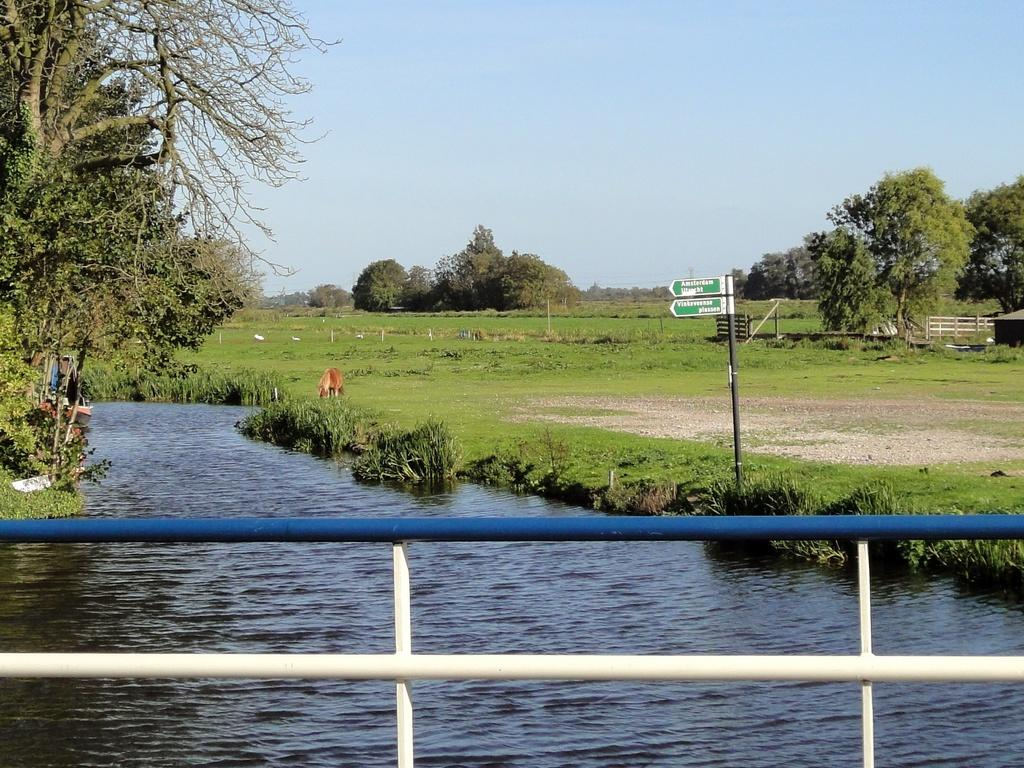What is located at the bottom of the image? There is a fence, water, a sign board, and grass at the bottom of the image. What can be seen in the background of the image? There are trees and a farm in the background of the image. What is visible at the top of the image? The sky is visible at the top of the image. When was the image taken? The image was taken during the day. How does the fog affect the balance of the trees in the image? There is no fog present in the image, so it cannot affect the balance of the trees. What type of trouble can be seen in the image? There is no trouble depicted in the image; it features a fence, water, a sign board, grass, trees, a farm, and the sky. 